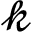<formula> <loc_0><loc_0><loc_500><loc_500>\mathcal { k }</formula> 